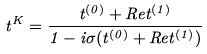Convert formula to latex. <formula><loc_0><loc_0><loc_500><loc_500>t ^ { K } = \frac { t ^ { ( 0 ) } + R e t ^ { ( 1 ) } } { 1 - i \sigma ( t ^ { ( 0 ) } + R e t ^ { ( 1 ) } ) }</formula> 